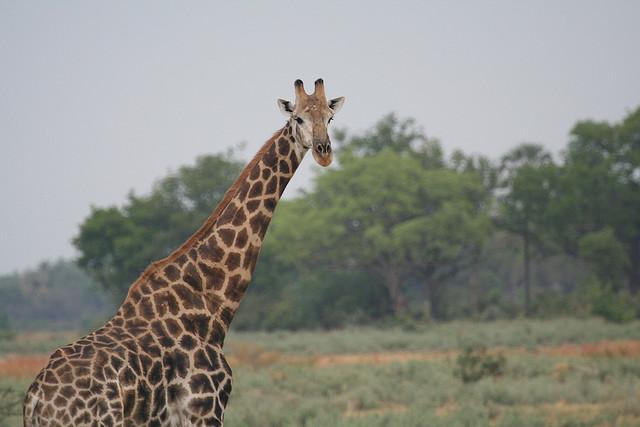Is this giraffe looking at the camera?
Keep it brief. Yes. Are the giraffes surrounded rock walls?
Short answer required. No. Do you think the giraffe is happy?
Concise answer only. Yes. Is this a full grown giraffe?
Give a very brief answer. Yes. Is there an animal only partially in frame?
Be succinct. Yes. Where is the animal?
Quick response, please. Giraffe. Is this a zoo?
Give a very brief answer. No. Where is the giraffe?
Keep it brief. Wild. Is this animal in the wild?
Short answer required. Yes. What kind of tree is to the right?
Write a very short answer. Maple. How many giraffe's are in the picture?
Answer briefly. 1. Does this giraffe appear to be in a zoo?
Concise answer only. No. Is the giraffe eating?
Keep it brief. No. Is the animal allowed to roam free?
Be succinct. Yes. Is the giraffe standing in water?
Concise answer only. No. What is the green stuff in the background?
Short answer required. Trees. Is this a baby giraffe?
Answer briefly. No. How many giraffes are in the image?
Concise answer only. 1. Is there a baby animal in this photo?
Be succinct. No. Are there any trees within the vicinity of the giraffes?
Keep it brief. Yes. Is the giraffe the king of the land?
Answer briefly. No. Are they in captivity?
Answer briefly. No. How many giraffes are there?
Be succinct. 1. Did someone put food there for the giraffe?
Write a very short answer. No. What is the giraffe looking at?
Answer briefly. Camera. Are the giraffes in the wild?
Concise answer only. Yes. Is it cloudy?
Concise answer only. Yes. How many giraffes are pictured?
Keep it brief. 1. Are these animals roaming free?
Quick response, please. Yes. Is the giraffe in the wild?
Answer briefly. Yes. IS this giraffe in the wild?
Concise answer only. Yes. Are there any other animals besides the giraffe's?
Short answer required. No. Is this giraffe very tall?
Be succinct. Yes. Is the giraffe standing upright?
Short answer required. Yes. Is the giraffe within a fenced area?
Keep it brief. No. How many giraffes?
Short answer required. 1. How many animals are there?
Answer briefly. 1. Is it a ZOO?
Concise answer only. No. Is the animal looking at the camera?
Short answer required. Yes. Is the giraffe hungry?
Quick response, please. No. Has the animal been caged?
Quick response, please. No. 